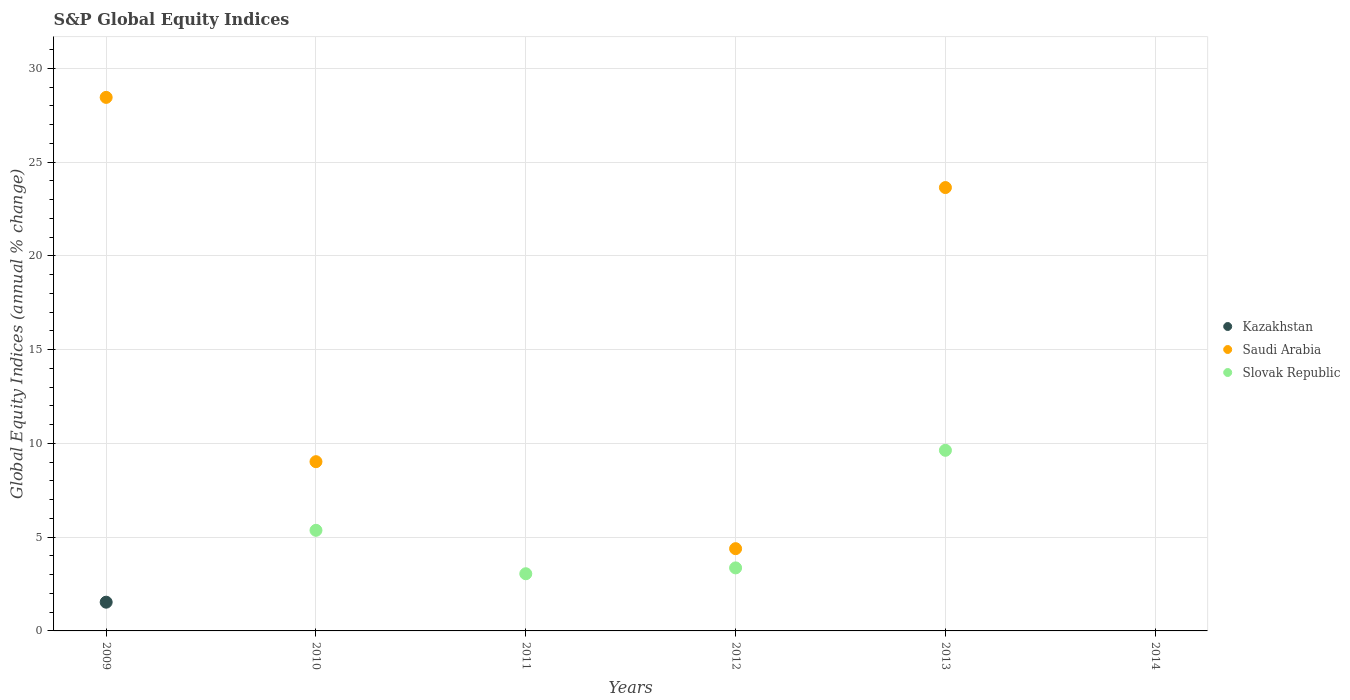How many different coloured dotlines are there?
Offer a very short reply. 3. What is the global equity indices in Slovak Republic in 2013?
Your answer should be compact. 9.63. Across all years, what is the maximum global equity indices in Saudi Arabia?
Provide a succinct answer. 28.45. Across all years, what is the minimum global equity indices in Slovak Republic?
Keep it short and to the point. 0. In which year was the global equity indices in Slovak Republic maximum?
Provide a succinct answer. 2013. What is the total global equity indices in Kazakhstan in the graph?
Your response must be concise. 1.53. What is the difference between the global equity indices in Slovak Republic in 2013 and the global equity indices in Saudi Arabia in 2010?
Provide a succinct answer. 0.61. What is the average global equity indices in Kazakhstan per year?
Provide a short and direct response. 0.26. In the year 2009, what is the difference between the global equity indices in Saudi Arabia and global equity indices in Kazakhstan?
Keep it short and to the point. 26.92. In how many years, is the global equity indices in Saudi Arabia greater than 27 %?
Your response must be concise. 1. Is the global equity indices in Saudi Arabia in 2012 less than that in 2013?
Your answer should be compact. Yes. What is the difference between the highest and the second highest global equity indices in Saudi Arabia?
Your answer should be compact. 4.81. What is the difference between the highest and the lowest global equity indices in Slovak Republic?
Ensure brevity in your answer.  9.63. In how many years, is the global equity indices in Saudi Arabia greater than the average global equity indices in Saudi Arabia taken over all years?
Make the answer very short. 2. Does the global equity indices in Slovak Republic monotonically increase over the years?
Offer a terse response. No. Is the global equity indices in Kazakhstan strictly greater than the global equity indices in Saudi Arabia over the years?
Provide a short and direct response. No. Is the global equity indices in Kazakhstan strictly less than the global equity indices in Slovak Republic over the years?
Your answer should be very brief. No. How many years are there in the graph?
Provide a short and direct response. 6. What is the difference between two consecutive major ticks on the Y-axis?
Make the answer very short. 5. Does the graph contain grids?
Your response must be concise. Yes. What is the title of the graph?
Your answer should be compact. S&P Global Equity Indices. What is the label or title of the X-axis?
Give a very brief answer. Years. What is the label or title of the Y-axis?
Give a very brief answer. Global Equity Indices (annual % change). What is the Global Equity Indices (annual % change) in Kazakhstan in 2009?
Your answer should be compact. 1.53. What is the Global Equity Indices (annual % change) of Saudi Arabia in 2009?
Offer a terse response. 28.45. What is the Global Equity Indices (annual % change) of Slovak Republic in 2009?
Provide a succinct answer. 0. What is the Global Equity Indices (annual % change) of Kazakhstan in 2010?
Your response must be concise. 0. What is the Global Equity Indices (annual % change) in Saudi Arabia in 2010?
Make the answer very short. 9.02. What is the Global Equity Indices (annual % change) in Slovak Republic in 2010?
Provide a succinct answer. 5.36. What is the Global Equity Indices (annual % change) of Saudi Arabia in 2011?
Keep it short and to the point. 0. What is the Global Equity Indices (annual % change) of Slovak Republic in 2011?
Your response must be concise. 3.05. What is the Global Equity Indices (annual % change) of Kazakhstan in 2012?
Provide a succinct answer. 0. What is the Global Equity Indices (annual % change) in Saudi Arabia in 2012?
Give a very brief answer. 4.39. What is the Global Equity Indices (annual % change) in Slovak Republic in 2012?
Make the answer very short. 3.36. What is the Global Equity Indices (annual % change) of Saudi Arabia in 2013?
Give a very brief answer. 23.64. What is the Global Equity Indices (annual % change) in Slovak Republic in 2013?
Your response must be concise. 9.63. What is the Global Equity Indices (annual % change) of Kazakhstan in 2014?
Provide a succinct answer. 0. Across all years, what is the maximum Global Equity Indices (annual % change) of Kazakhstan?
Your response must be concise. 1.53. Across all years, what is the maximum Global Equity Indices (annual % change) of Saudi Arabia?
Your response must be concise. 28.45. Across all years, what is the maximum Global Equity Indices (annual % change) in Slovak Republic?
Your answer should be very brief. 9.63. Across all years, what is the minimum Global Equity Indices (annual % change) in Kazakhstan?
Provide a succinct answer. 0. What is the total Global Equity Indices (annual % change) in Kazakhstan in the graph?
Keep it short and to the point. 1.53. What is the total Global Equity Indices (annual % change) of Saudi Arabia in the graph?
Your answer should be very brief. 65.5. What is the total Global Equity Indices (annual % change) of Slovak Republic in the graph?
Your answer should be compact. 21.41. What is the difference between the Global Equity Indices (annual % change) of Saudi Arabia in 2009 and that in 2010?
Your answer should be very brief. 19.43. What is the difference between the Global Equity Indices (annual % change) of Saudi Arabia in 2009 and that in 2012?
Ensure brevity in your answer.  24.06. What is the difference between the Global Equity Indices (annual % change) in Saudi Arabia in 2009 and that in 2013?
Make the answer very short. 4.81. What is the difference between the Global Equity Indices (annual % change) of Slovak Republic in 2010 and that in 2011?
Your response must be concise. 2.32. What is the difference between the Global Equity Indices (annual % change) of Saudi Arabia in 2010 and that in 2012?
Offer a terse response. 4.64. What is the difference between the Global Equity Indices (annual % change) in Slovak Republic in 2010 and that in 2012?
Offer a terse response. 2. What is the difference between the Global Equity Indices (annual % change) of Saudi Arabia in 2010 and that in 2013?
Make the answer very short. -14.62. What is the difference between the Global Equity Indices (annual % change) in Slovak Republic in 2010 and that in 2013?
Your answer should be compact. -4.27. What is the difference between the Global Equity Indices (annual % change) of Slovak Republic in 2011 and that in 2012?
Give a very brief answer. -0.31. What is the difference between the Global Equity Indices (annual % change) of Slovak Republic in 2011 and that in 2013?
Offer a terse response. -6.58. What is the difference between the Global Equity Indices (annual % change) of Saudi Arabia in 2012 and that in 2013?
Offer a terse response. -19.26. What is the difference between the Global Equity Indices (annual % change) of Slovak Republic in 2012 and that in 2013?
Keep it short and to the point. -6.27. What is the difference between the Global Equity Indices (annual % change) of Kazakhstan in 2009 and the Global Equity Indices (annual % change) of Saudi Arabia in 2010?
Provide a short and direct response. -7.49. What is the difference between the Global Equity Indices (annual % change) of Kazakhstan in 2009 and the Global Equity Indices (annual % change) of Slovak Republic in 2010?
Provide a succinct answer. -3.83. What is the difference between the Global Equity Indices (annual % change) of Saudi Arabia in 2009 and the Global Equity Indices (annual % change) of Slovak Republic in 2010?
Provide a succinct answer. 23.09. What is the difference between the Global Equity Indices (annual % change) in Kazakhstan in 2009 and the Global Equity Indices (annual % change) in Slovak Republic in 2011?
Provide a short and direct response. -1.52. What is the difference between the Global Equity Indices (annual % change) in Saudi Arabia in 2009 and the Global Equity Indices (annual % change) in Slovak Republic in 2011?
Give a very brief answer. 25.4. What is the difference between the Global Equity Indices (annual % change) in Kazakhstan in 2009 and the Global Equity Indices (annual % change) in Saudi Arabia in 2012?
Offer a terse response. -2.85. What is the difference between the Global Equity Indices (annual % change) of Kazakhstan in 2009 and the Global Equity Indices (annual % change) of Slovak Republic in 2012?
Make the answer very short. -1.83. What is the difference between the Global Equity Indices (annual % change) of Saudi Arabia in 2009 and the Global Equity Indices (annual % change) of Slovak Republic in 2012?
Offer a terse response. 25.09. What is the difference between the Global Equity Indices (annual % change) in Kazakhstan in 2009 and the Global Equity Indices (annual % change) in Saudi Arabia in 2013?
Your answer should be very brief. -22.11. What is the difference between the Global Equity Indices (annual % change) of Kazakhstan in 2009 and the Global Equity Indices (annual % change) of Slovak Republic in 2013?
Your answer should be very brief. -8.1. What is the difference between the Global Equity Indices (annual % change) in Saudi Arabia in 2009 and the Global Equity Indices (annual % change) in Slovak Republic in 2013?
Give a very brief answer. 18.82. What is the difference between the Global Equity Indices (annual % change) in Saudi Arabia in 2010 and the Global Equity Indices (annual % change) in Slovak Republic in 2011?
Offer a very short reply. 5.98. What is the difference between the Global Equity Indices (annual % change) of Saudi Arabia in 2010 and the Global Equity Indices (annual % change) of Slovak Republic in 2012?
Keep it short and to the point. 5.66. What is the difference between the Global Equity Indices (annual % change) in Saudi Arabia in 2010 and the Global Equity Indices (annual % change) in Slovak Republic in 2013?
Offer a terse response. -0.61. What is the difference between the Global Equity Indices (annual % change) of Saudi Arabia in 2012 and the Global Equity Indices (annual % change) of Slovak Republic in 2013?
Your answer should be very brief. -5.25. What is the average Global Equity Indices (annual % change) of Kazakhstan per year?
Ensure brevity in your answer.  0.26. What is the average Global Equity Indices (annual % change) in Saudi Arabia per year?
Your response must be concise. 10.92. What is the average Global Equity Indices (annual % change) in Slovak Republic per year?
Provide a short and direct response. 3.57. In the year 2009, what is the difference between the Global Equity Indices (annual % change) in Kazakhstan and Global Equity Indices (annual % change) in Saudi Arabia?
Ensure brevity in your answer.  -26.92. In the year 2010, what is the difference between the Global Equity Indices (annual % change) of Saudi Arabia and Global Equity Indices (annual % change) of Slovak Republic?
Make the answer very short. 3.66. In the year 2012, what is the difference between the Global Equity Indices (annual % change) in Saudi Arabia and Global Equity Indices (annual % change) in Slovak Republic?
Ensure brevity in your answer.  1.03. In the year 2013, what is the difference between the Global Equity Indices (annual % change) of Saudi Arabia and Global Equity Indices (annual % change) of Slovak Republic?
Make the answer very short. 14.01. What is the ratio of the Global Equity Indices (annual % change) of Saudi Arabia in 2009 to that in 2010?
Your answer should be very brief. 3.15. What is the ratio of the Global Equity Indices (annual % change) in Saudi Arabia in 2009 to that in 2012?
Provide a succinct answer. 6.49. What is the ratio of the Global Equity Indices (annual % change) in Saudi Arabia in 2009 to that in 2013?
Provide a short and direct response. 1.2. What is the ratio of the Global Equity Indices (annual % change) of Slovak Republic in 2010 to that in 2011?
Your response must be concise. 1.76. What is the ratio of the Global Equity Indices (annual % change) of Saudi Arabia in 2010 to that in 2012?
Offer a terse response. 2.06. What is the ratio of the Global Equity Indices (annual % change) of Slovak Republic in 2010 to that in 2012?
Your answer should be compact. 1.6. What is the ratio of the Global Equity Indices (annual % change) of Saudi Arabia in 2010 to that in 2013?
Ensure brevity in your answer.  0.38. What is the ratio of the Global Equity Indices (annual % change) of Slovak Republic in 2010 to that in 2013?
Provide a short and direct response. 0.56. What is the ratio of the Global Equity Indices (annual % change) in Slovak Republic in 2011 to that in 2012?
Your answer should be very brief. 0.91. What is the ratio of the Global Equity Indices (annual % change) in Slovak Republic in 2011 to that in 2013?
Make the answer very short. 0.32. What is the ratio of the Global Equity Indices (annual % change) of Saudi Arabia in 2012 to that in 2013?
Your response must be concise. 0.19. What is the ratio of the Global Equity Indices (annual % change) in Slovak Republic in 2012 to that in 2013?
Offer a very short reply. 0.35. What is the difference between the highest and the second highest Global Equity Indices (annual % change) of Saudi Arabia?
Offer a very short reply. 4.81. What is the difference between the highest and the second highest Global Equity Indices (annual % change) in Slovak Republic?
Your response must be concise. 4.27. What is the difference between the highest and the lowest Global Equity Indices (annual % change) of Kazakhstan?
Provide a succinct answer. 1.53. What is the difference between the highest and the lowest Global Equity Indices (annual % change) in Saudi Arabia?
Make the answer very short. 28.45. What is the difference between the highest and the lowest Global Equity Indices (annual % change) in Slovak Republic?
Ensure brevity in your answer.  9.63. 